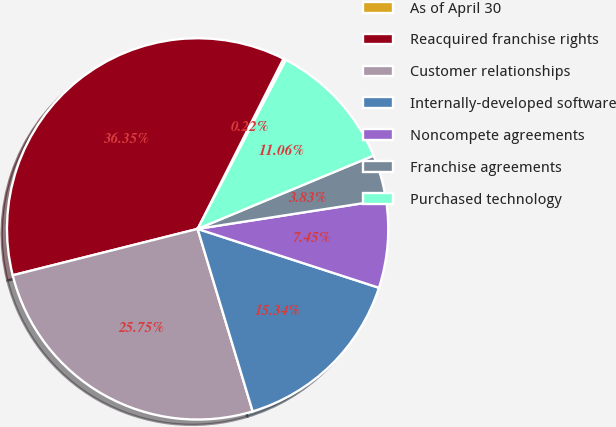Convert chart. <chart><loc_0><loc_0><loc_500><loc_500><pie_chart><fcel>As of April 30<fcel>Reacquired franchise rights<fcel>Customer relationships<fcel>Internally-developed software<fcel>Noncompete agreements<fcel>Franchise agreements<fcel>Purchased technology<nl><fcel>0.22%<fcel>36.35%<fcel>25.75%<fcel>15.34%<fcel>7.45%<fcel>3.83%<fcel>11.06%<nl></chart> 